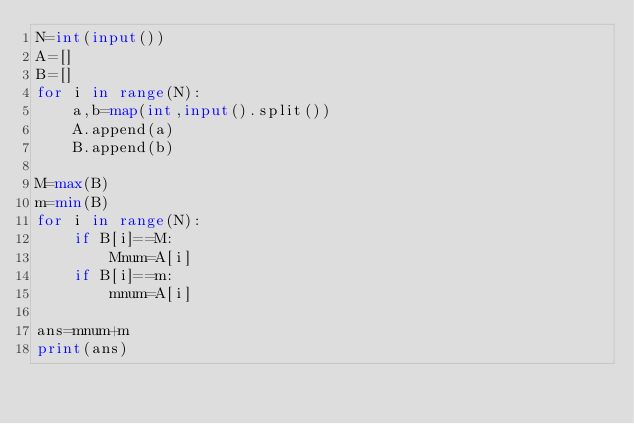<code> <loc_0><loc_0><loc_500><loc_500><_Python_>N=int(input())
A=[]
B=[]
for i in range(N):
    a,b=map(int,input().split())
    A.append(a)
    B.append(b)

M=max(B)
m=min(B)
for i in range(N):
    if B[i]==M:
        Mnum=A[i]
    if B[i]==m:
        mnum=A[i]

ans=mnum+m
print(ans)</code> 